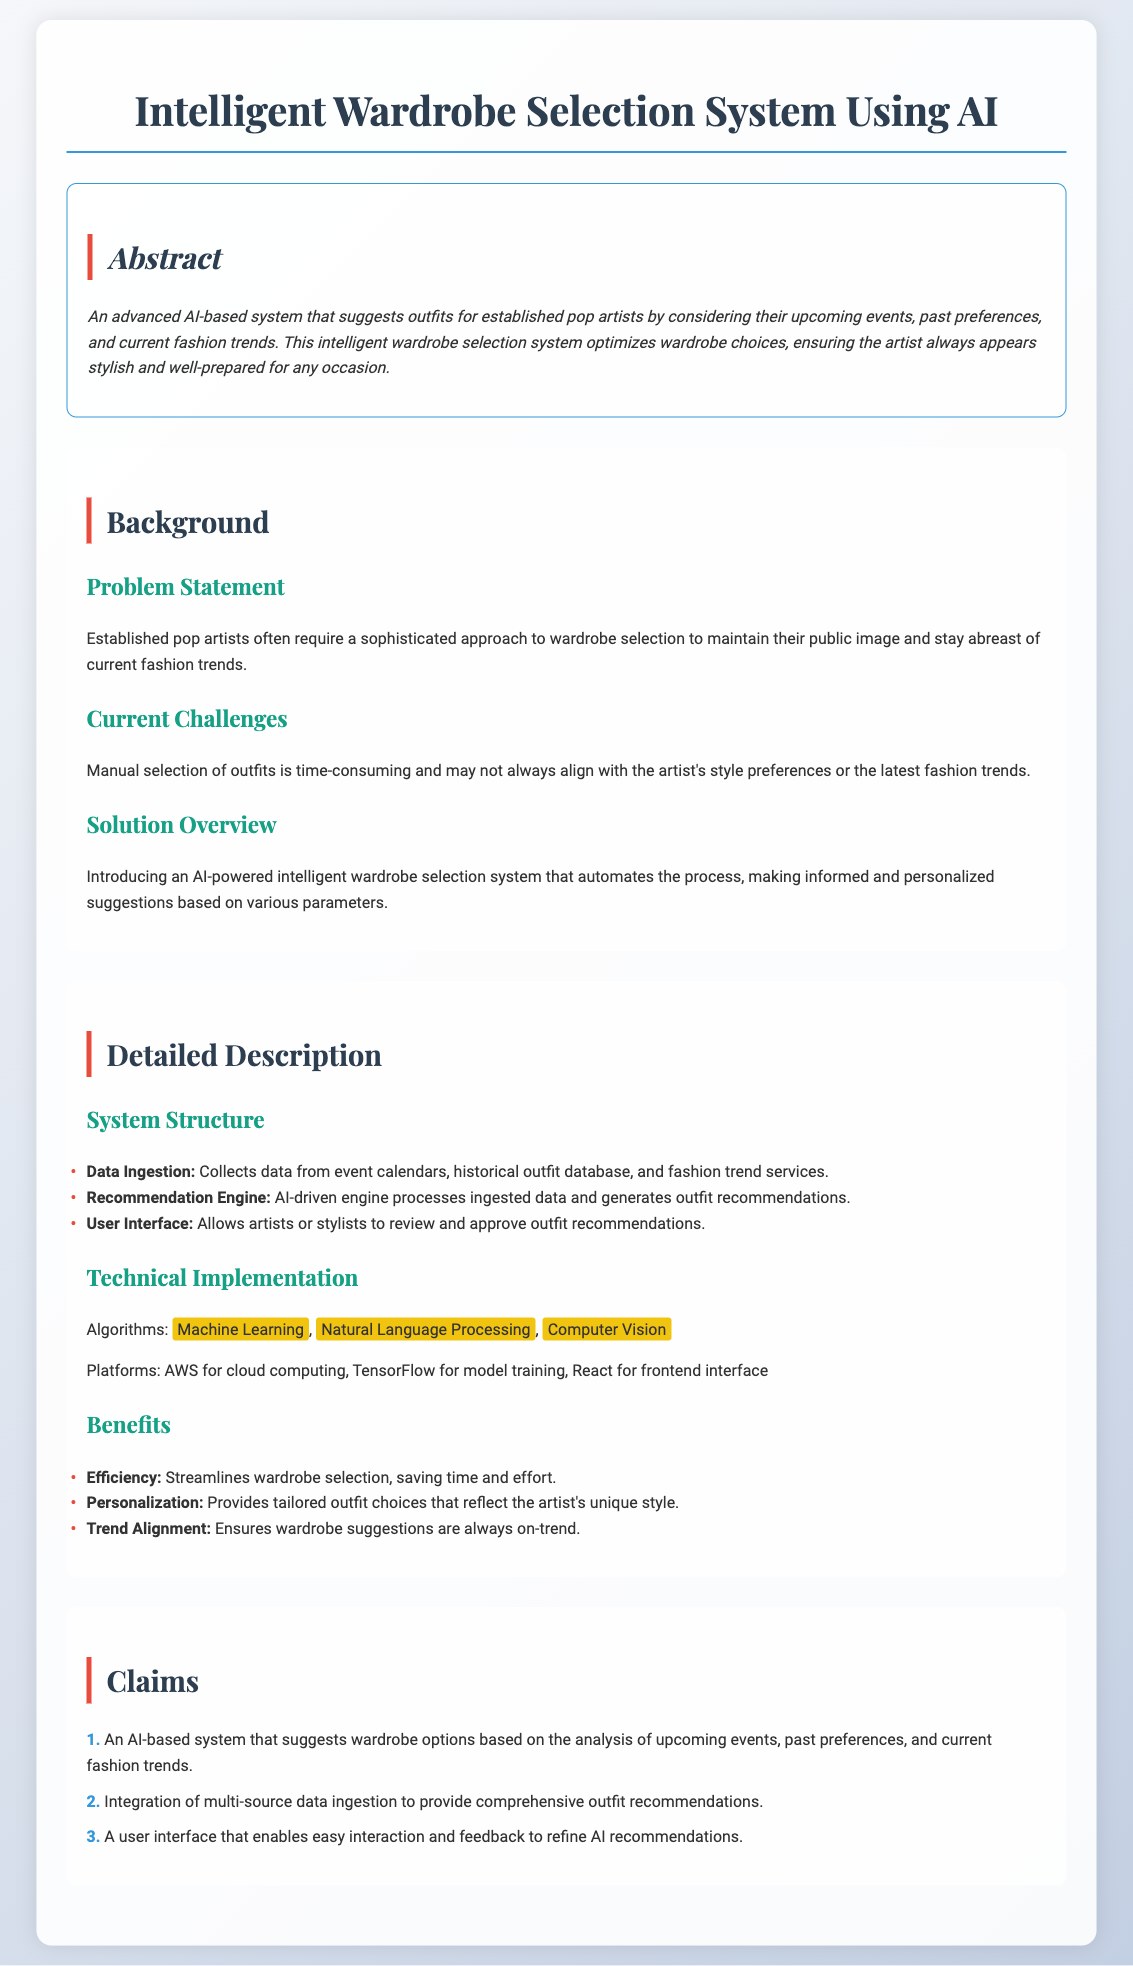What is the title of the system? The title of the system is given in the document's headline.
Answer: Intelligent Wardrobe Selection System Using AI What is the purpose of the system? The purpose is described in the abstract section of the document.
Answer: Suggests outfits What technologies are mentioned in the technical implementation? The technologies listed in the technical implementation provide insight into the system's building blocks.
Answer: Machine Learning, Natural Language Processing, Computer Vision What type of data does the system collect? The types of data collected are outlined in the system structure section.
Answer: Event calendars, historical outfit database, fashion trend services What benefit of the system is highlighted first? The benefits are listed in the benefits section, revealing the most emphasized advantage.
Answer: Efficiency How many claims does the document present? The number of claims is specified in the claims section of the document.
Answer: Three What is the main user of the system? The primary user is suggested in the abstract and detailed description.
Answer: Established pop artists What does the user interface allow? The capability of the user interface is mentioned in the detailed description section.
Answer: Review and approve outfit recommendations What problem does the system aim to solve? The problem statement outlines the main issue that the system addresses.
Answer: Time-consuming outfit selection 